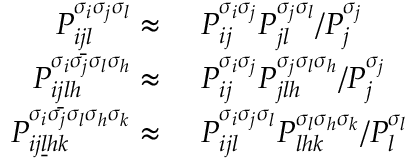Convert formula to latex. <formula><loc_0><loc_0><loc_500><loc_500>\begin{array} { r l } { P _ { i \underline { j } l } ^ { \sigma _ { i } \sigma _ { j } \sigma _ { l } } \approx } & { \ P _ { i j } ^ { \sigma _ { i } \sigma _ { j } } P _ { j l } ^ { \sigma _ { j } \sigma _ { l } } / P _ { j } ^ { \sigma _ { j } } } \\ { P _ { i \underline { j } l h } ^ { \sigma _ { i } \sigma _ { j } \sigma _ { l } \sigma _ { h } } \approx } & { \ P _ { i j } ^ { \sigma _ { i } \sigma _ { j } } P _ { j l h } ^ { \sigma _ { j } \sigma _ { l } \sigma _ { h } } / P _ { j } ^ { \sigma _ { j } } } \\ { P _ { i j \underline { l } h k } ^ { \sigma _ { i } \sigma _ { j } \sigma _ { l } \sigma _ { h } \sigma _ { k } } \approx } & { \ P _ { i j l } ^ { \sigma _ { i } \sigma _ { j } \sigma _ { l } } P _ { l h k } ^ { \sigma _ { l } \sigma _ { h } \sigma _ { k } } / P _ { l } ^ { \sigma _ { l } } } \end{array}</formula> 